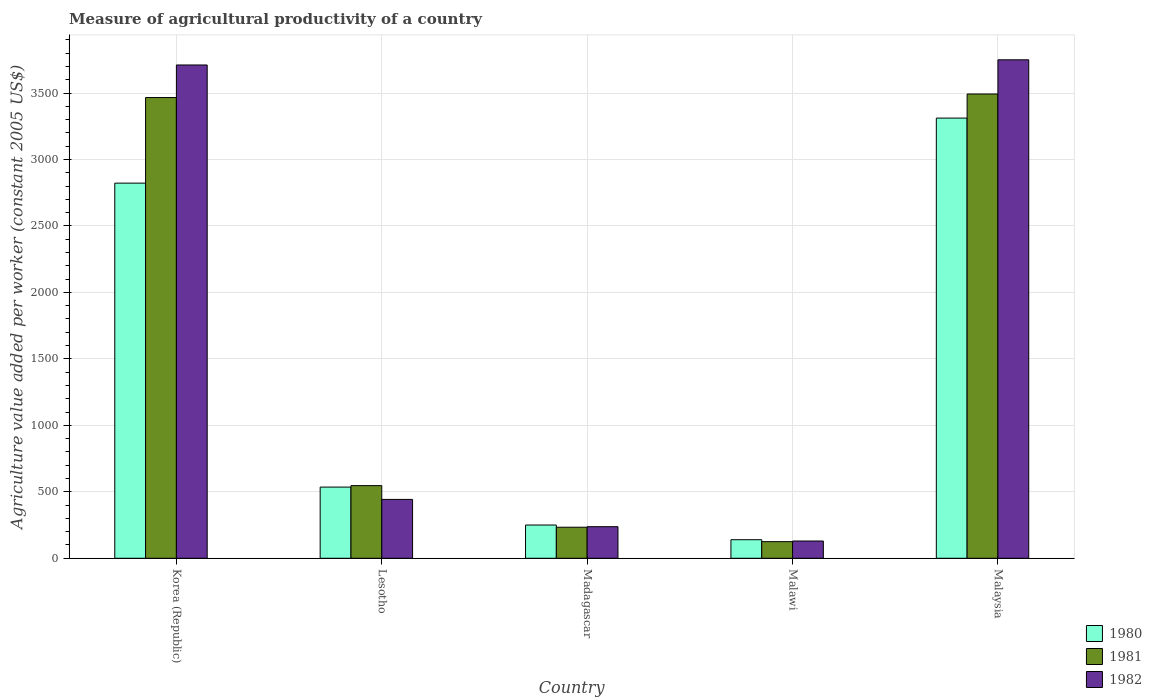How many groups of bars are there?
Offer a terse response. 5. Are the number of bars on each tick of the X-axis equal?
Provide a succinct answer. Yes. How many bars are there on the 4th tick from the right?
Keep it short and to the point. 3. What is the label of the 2nd group of bars from the left?
Ensure brevity in your answer.  Lesotho. What is the measure of agricultural productivity in 1981 in Malawi?
Provide a succinct answer. 124.86. Across all countries, what is the maximum measure of agricultural productivity in 1980?
Your response must be concise. 3311.27. Across all countries, what is the minimum measure of agricultural productivity in 1982?
Provide a succinct answer. 129.9. In which country was the measure of agricultural productivity in 1981 maximum?
Ensure brevity in your answer.  Malaysia. In which country was the measure of agricultural productivity in 1981 minimum?
Your answer should be very brief. Malawi. What is the total measure of agricultural productivity in 1981 in the graph?
Ensure brevity in your answer.  7863.25. What is the difference between the measure of agricultural productivity in 1982 in Lesotho and that in Malaysia?
Your response must be concise. -3307.03. What is the difference between the measure of agricultural productivity in 1982 in Malawi and the measure of agricultural productivity in 1980 in Korea (Republic)?
Keep it short and to the point. -2692.08. What is the average measure of agricultural productivity in 1982 per country?
Offer a terse response. 1654.19. What is the difference between the measure of agricultural productivity of/in 1982 and measure of agricultural productivity of/in 1980 in Malaysia?
Give a very brief answer. 438.53. What is the ratio of the measure of agricultural productivity in 1981 in Madagascar to that in Malaysia?
Provide a short and direct response. 0.07. Is the measure of agricultural productivity in 1980 in Lesotho less than that in Malawi?
Provide a succinct answer. No. What is the difference between the highest and the second highest measure of agricultural productivity in 1980?
Your answer should be very brief. -2286.45. What is the difference between the highest and the lowest measure of agricultural productivity in 1980?
Give a very brief answer. 3171.65. What does the 3rd bar from the left in Korea (Republic) represents?
Offer a very short reply. 1982. What does the 3rd bar from the right in Malaysia represents?
Provide a succinct answer. 1980. How many bars are there?
Offer a terse response. 15. Are all the bars in the graph horizontal?
Your answer should be very brief. No. Does the graph contain any zero values?
Make the answer very short. No. Does the graph contain grids?
Offer a very short reply. Yes. What is the title of the graph?
Offer a very short reply. Measure of agricultural productivity of a country. What is the label or title of the X-axis?
Provide a succinct answer. Country. What is the label or title of the Y-axis?
Offer a very short reply. Agriculture value added per worker (constant 2005 US$). What is the Agriculture value added per worker (constant 2005 US$) in 1980 in Korea (Republic)?
Offer a terse response. 2821.97. What is the Agriculture value added per worker (constant 2005 US$) of 1981 in Korea (Republic)?
Give a very brief answer. 3465.84. What is the Agriculture value added per worker (constant 2005 US$) in 1982 in Korea (Republic)?
Give a very brief answer. 3710.82. What is the Agriculture value added per worker (constant 2005 US$) in 1980 in Lesotho?
Ensure brevity in your answer.  535.53. What is the Agriculture value added per worker (constant 2005 US$) of 1981 in Lesotho?
Provide a succinct answer. 546.43. What is the Agriculture value added per worker (constant 2005 US$) of 1982 in Lesotho?
Your response must be concise. 442.77. What is the Agriculture value added per worker (constant 2005 US$) of 1980 in Madagascar?
Your answer should be compact. 250.1. What is the Agriculture value added per worker (constant 2005 US$) of 1981 in Madagascar?
Give a very brief answer. 233.51. What is the Agriculture value added per worker (constant 2005 US$) in 1982 in Madagascar?
Ensure brevity in your answer.  237.65. What is the Agriculture value added per worker (constant 2005 US$) in 1980 in Malawi?
Your answer should be very brief. 139.62. What is the Agriculture value added per worker (constant 2005 US$) of 1981 in Malawi?
Keep it short and to the point. 124.86. What is the Agriculture value added per worker (constant 2005 US$) of 1982 in Malawi?
Keep it short and to the point. 129.9. What is the Agriculture value added per worker (constant 2005 US$) of 1980 in Malaysia?
Ensure brevity in your answer.  3311.27. What is the Agriculture value added per worker (constant 2005 US$) of 1981 in Malaysia?
Provide a succinct answer. 3492.6. What is the Agriculture value added per worker (constant 2005 US$) in 1982 in Malaysia?
Provide a succinct answer. 3749.8. Across all countries, what is the maximum Agriculture value added per worker (constant 2005 US$) of 1980?
Your answer should be very brief. 3311.27. Across all countries, what is the maximum Agriculture value added per worker (constant 2005 US$) of 1981?
Your answer should be very brief. 3492.6. Across all countries, what is the maximum Agriculture value added per worker (constant 2005 US$) in 1982?
Keep it short and to the point. 3749.8. Across all countries, what is the minimum Agriculture value added per worker (constant 2005 US$) of 1980?
Give a very brief answer. 139.62. Across all countries, what is the minimum Agriculture value added per worker (constant 2005 US$) in 1981?
Make the answer very short. 124.86. Across all countries, what is the minimum Agriculture value added per worker (constant 2005 US$) of 1982?
Your response must be concise. 129.9. What is the total Agriculture value added per worker (constant 2005 US$) of 1980 in the graph?
Provide a short and direct response. 7058.5. What is the total Agriculture value added per worker (constant 2005 US$) in 1981 in the graph?
Provide a short and direct response. 7863.25. What is the total Agriculture value added per worker (constant 2005 US$) of 1982 in the graph?
Keep it short and to the point. 8270.93. What is the difference between the Agriculture value added per worker (constant 2005 US$) of 1980 in Korea (Republic) and that in Lesotho?
Ensure brevity in your answer.  2286.45. What is the difference between the Agriculture value added per worker (constant 2005 US$) of 1981 in Korea (Republic) and that in Lesotho?
Provide a succinct answer. 2919.41. What is the difference between the Agriculture value added per worker (constant 2005 US$) in 1982 in Korea (Republic) and that in Lesotho?
Offer a very short reply. 3268.05. What is the difference between the Agriculture value added per worker (constant 2005 US$) of 1980 in Korea (Republic) and that in Madagascar?
Offer a very short reply. 2571.88. What is the difference between the Agriculture value added per worker (constant 2005 US$) of 1981 in Korea (Republic) and that in Madagascar?
Provide a succinct answer. 3232.33. What is the difference between the Agriculture value added per worker (constant 2005 US$) in 1982 in Korea (Republic) and that in Madagascar?
Keep it short and to the point. 3473.17. What is the difference between the Agriculture value added per worker (constant 2005 US$) of 1980 in Korea (Republic) and that in Malawi?
Make the answer very short. 2682.35. What is the difference between the Agriculture value added per worker (constant 2005 US$) of 1981 in Korea (Republic) and that in Malawi?
Your response must be concise. 3340.98. What is the difference between the Agriculture value added per worker (constant 2005 US$) of 1982 in Korea (Republic) and that in Malawi?
Your response must be concise. 3580.92. What is the difference between the Agriculture value added per worker (constant 2005 US$) of 1980 in Korea (Republic) and that in Malaysia?
Offer a terse response. -489.3. What is the difference between the Agriculture value added per worker (constant 2005 US$) in 1981 in Korea (Republic) and that in Malaysia?
Your answer should be compact. -26.76. What is the difference between the Agriculture value added per worker (constant 2005 US$) of 1982 in Korea (Republic) and that in Malaysia?
Your answer should be very brief. -38.98. What is the difference between the Agriculture value added per worker (constant 2005 US$) of 1980 in Lesotho and that in Madagascar?
Your response must be concise. 285.43. What is the difference between the Agriculture value added per worker (constant 2005 US$) of 1981 in Lesotho and that in Madagascar?
Offer a terse response. 312.92. What is the difference between the Agriculture value added per worker (constant 2005 US$) in 1982 in Lesotho and that in Madagascar?
Make the answer very short. 205.12. What is the difference between the Agriculture value added per worker (constant 2005 US$) in 1980 in Lesotho and that in Malawi?
Ensure brevity in your answer.  395.9. What is the difference between the Agriculture value added per worker (constant 2005 US$) of 1981 in Lesotho and that in Malawi?
Keep it short and to the point. 421.57. What is the difference between the Agriculture value added per worker (constant 2005 US$) in 1982 in Lesotho and that in Malawi?
Provide a short and direct response. 312.87. What is the difference between the Agriculture value added per worker (constant 2005 US$) in 1980 in Lesotho and that in Malaysia?
Keep it short and to the point. -2775.74. What is the difference between the Agriculture value added per worker (constant 2005 US$) of 1981 in Lesotho and that in Malaysia?
Your answer should be very brief. -2946.17. What is the difference between the Agriculture value added per worker (constant 2005 US$) of 1982 in Lesotho and that in Malaysia?
Provide a succinct answer. -3307.03. What is the difference between the Agriculture value added per worker (constant 2005 US$) in 1980 in Madagascar and that in Malawi?
Offer a very short reply. 110.47. What is the difference between the Agriculture value added per worker (constant 2005 US$) in 1981 in Madagascar and that in Malawi?
Your response must be concise. 108.65. What is the difference between the Agriculture value added per worker (constant 2005 US$) of 1982 in Madagascar and that in Malawi?
Provide a succinct answer. 107.75. What is the difference between the Agriculture value added per worker (constant 2005 US$) in 1980 in Madagascar and that in Malaysia?
Ensure brevity in your answer.  -3061.17. What is the difference between the Agriculture value added per worker (constant 2005 US$) of 1981 in Madagascar and that in Malaysia?
Your response must be concise. -3259.09. What is the difference between the Agriculture value added per worker (constant 2005 US$) of 1982 in Madagascar and that in Malaysia?
Ensure brevity in your answer.  -3512.15. What is the difference between the Agriculture value added per worker (constant 2005 US$) of 1980 in Malawi and that in Malaysia?
Your response must be concise. -3171.65. What is the difference between the Agriculture value added per worker (constant 2005 US$) in 1981 in Malawi and that in Malaysia?
Provide a succinct answer. -3367.74. What is the difference between the Agriculture value added per worker (constant 2005 US$) of 1982 in Malawi and that in Malaysia?
Your response must be concise. -3619.9. What is the difference between the Agriculture value added per worker (constant 2005 US$) of 1980 in Korea (Republic) and the Agriculture value added per worker (constant 2005 US$) of 1981 in Lesotho?
Offer a very short reply. 2275.55. What is the difference between the Agriculture value added per worker (constant 2005 US$) in 1980 in Korea (Republic) and the Agriculture value added per worker (constant 2005 US$) in 1982 in Lesotho?
Keep it short and to the point. 2379.21. What is the difference between the Agriculture value added per worker (constant 2005 US$) of 1981 in Korea (Republic) and the Agriculture value added per worker (constant 2005 US$) of 1982 in Lesotho?
Ensure brevity in your answer.  3023.08. What is the difference between the Agriculture value added per worker (constant 2005 US$) of 1980 in Korea (Republic) and the Agriculture value added per worker (constant 2005 US$) of 1981 in Madagascar?
Your response must be concise. 2588.46. What is the difference between the Agriculture value added per worker (constant 2005 US$) of 1980 in Korea (Republic) and the Agriculture value added per worker (constant 2005 US$) of 1982 in Madagascar?
Offer a very short reply. 2584.33. What is the difference between the Agriculture value added per worker (constant 2005 US$) in 1981 in Korea (Republic) and the Agriculture value added per worker (constant 2005 US$) in 1982 in Madagascar?
Ensure brevity in your answer.  3228.2. What is the difference between the Agriculture value added per worker (constant 2005 US$) in 1980 in Korea (Republic) and the Agriculture value added per worker (constant 2005 US$) in 1981 in Malawi?
Offer a very short reply. 2697.11. What is the difference between the Agriculture value added per worker (constant 2005 US$) in 1980 in Korea (Republic) and the Agriculture value added per worker (constant 2005 US$) in 1982 in Malawi?
Your response must be concise. 2692.08. What is the difference between the Agriculture value added per worker (constant 2005 US$) in 1981 in Korea (Republic) and the Agriculture value added per worker (constant 2005 US$) in 1982 in Malawi?
Ensure brevity in your answer.  3335.95. What is the difference between the Agriculture value added per worker (constant 2005 US$) in 1980 in Korea (Republic) and the Agriculture value added per worker (constant 2005 US$) in 1981 in Malaysia?
Make the answer very short. -670.63. What is the difference between the Agriculture value added per worker (constant 2005 US$) of 1980 in Korea (Republic) and the Agriculture value added per worker (constant 2005 US$) of 1982 in Malaysia?
Give a very brief answer. -927.83. What is the difference between the Agriculture value added per worker (constant 2005 US$) of 1981 in Korea (Republic) and the Agriculture value added per worker (constant 2005 US$) of 1982 in Malaysia?
Your answer should be very brief. -283.96. What is the difference between the Agriculture value added per worker (constant 2005 US$) of 1980 in Lesotho and the Agriculture value added per worker (constant 2005 US$) of 1981 in Madagascar?
Offer a terse response. 302.02. What is the difference between the Agriculture value added per worker (constant 2005 US$) of 1980 in Lesotho and the Agriculture value added per worker (constant 2005 US$) of 1982 in Madagascar?
Offer a very short reply. 297.88. What is the difference between the Agriculture value added per worker (constant 2005 US$) in 1981 in Lesotho and the Agriculture value added per worker (constant 2005 US$) in 1982 in Madagascar?
Your answer should be very brief. 308.78. What is the difference between the Agriculture value added per worker (constant 2005 US$) in 1980 in Lesotho and the Agriculture value added per worker (constant 2005 US$) in 1981 in Malawi?
Your response must be concise. 410.66. What is the difference between the Agriculture value added per worker (constant 2005 US$) of 1980 in Lesotho and the Agriculture value added per worker (constant 2005 US$) of 1982 in Malawi?
Offer a very short reply. 405.63. What is the difference between the Agriculture value added per worker (constant 2005 US$) in 1981 in Lesotho and the Agriculture value added per worker (constant 2005 US$) in 1982 in Malawi?
Provide a succinct answer. 416.53. What is the difference between the Agriculture value added per worker (constant 2005 US$) of 1980 in Lesotho and the Agriculture value added per worker (constant 2005 US$) of 1981 in Malaysia?
Give a very brief answer. -2957.07. What is the difference between the Agriculture value added per worker (constant 2005 US$) of 1980 in Lesotho and the Agriculture value added per worker (constant 2005 US$) of 1982 in Malaysia?
Give a very brief answer. -3214.27. What is the difference between the Agriculture value added per worker (constant 2005 US$) of 1981 in Lesotho and the Agriculture value added per worker (constant 2005 US$) of 1982 in Malaysia?
Offer a very short reply. -3203.37. What is the difference between the Agriculture value added per worker (constant 2005 US$) of 1980 in Madagascar and the Agriculture value added per worker (constant 2005 US$) of 1981 in Malawi?
Keep it short and to the point. 125.24. What is the difference between the Agriculture value added per worker (constant 2005 US$) of 1980 in Madagascar and the Agriculture value added per worker (constant 2005 US$) of 1982 in Malawi?
Provide a succinct answer. 120.2. What is the difference between the Agriculture value added per worker (constant 2005 US$) of 1981 in Madagascar and the Agriculture value added per worker (constant 2005 US$) of 1982 in Malawi?
Offer a terse response. 103.61. What is the difference between the Agriculture value added per worker (constant 2005 US$) in 1980 in Madagascar and the Agriculture value added per worker (constant 2005 US$) in 1981 in Malaysia?
Provide a succinct answer. -3242.5. What is the difference between the Agriculture value added per worker (constant 2005 US$) in 1980 in Madagascar and the Agriculture value added per worker (constant 2005 US$) in 1982 in Malaysia?
Keep it short and to the point. -3499.7. What is the difference between the Agriculture value added per worker (constant 2005 US$) of 1981 in Madagascar and the Agriculture value added per worker (constant 2005 US$) of 1982 in Malaysia?
Provide a succinct answer. -3516.29. What is the difference between the Agriculture value added per worker (constant 2005 US$) of 1980 in Malawi and the Agriculture value added per worker (constant 2005 US$) of 1981 in Malaysia?
Your answer should be compact. -3352.98. What is the difference between the Agriculture value added per worker (constant 2005 US$) of 1980 in Malawi and the Agriculture value added per worker (constant 2005 US$) of 1982 in Malaysia?
Make the answer very short. -3610.18. What is the difference between the Agriculture value added per worker (constant 2005 US$) of 1981 in Malawi and the Agriculture value added per worker (constant 2005 US$) of 1982 in Malaysia?
Make the answer very short. -3624.94. What is the average Agriculture value added per worker (constant 2005 US$) of 1980 per country?
Keep it short and to the point. 1411.7. What is the average Agriculture value added per worker (constant 2005 US$) in 1981 per country?
Keep it short and to the point. 1572.65. What is the average Agriculture value added per worker (constant 2005 US$) in 1982 per country?
Your answer should be very brief. 1654.19. What is the difference between the Agriculture value added per worker (constant 2005 US$) of 1980 and Agriculture value added per worker (constant 2005 US$) of 1981 in Korea (Republic)?
Your answer should be very brief. -643.87. What is the difference between the Agriculture value added per worker (constant 2005 US$) in 1980 and Agriculture value added per worker (constant 2005 US$) in 1982 in Korea (Republic)?
Make the answer very short. -888.84. What is the difference between the Agriculture value added per worker (constant 2005 US$) of 1981 and Agriculture value added per worker (constant 2005 US$) of 1982 in Korea (Republic)?
Make the answer very short. -244.97. What is the difference between the Agriculture value added per worker (constant 2005 US$) of 1980 and Agriculture value added per worker (constant 2005 US$) of 1981 in Lesotho?
Your response must be concise. -10.9. What is the difference between the Agriculture value added per worker (constant 2005 US$) of 1980 and Agriculture value added per worker (constant 2005 US$) of 1982 in Lesotho?
Your answer should be compact. 92.76. What is the difference between the Agriculture value added per worker (constant 2005 US$) of 1981 and Agriculture value added per worker (constant 2005 US$) of 1982 in Lesotho?
Your answer should be very brief. 103.66. What is the difference between the Agriculture value added per worker (constant 2005 US$) of 1980 and Agriculture value added per worker (constant 2005 US$) of 1981 in Madagascar?
Offer a terse response. 16.59. What is the difference between the Agriculture value added per worker (constant 2005 US$) in 1980 and Agriculture value added per worker (constant 2005 US$) in 1982 in Madagascar?
Offer a very short reply. 12.45. What is the difference between the Agriculture value added per worker (constant 2005 US$) of 1981 and Agriculture value added per worker (constant 2005 US$) of 1982 in Madagascar?
Your response must be concise. -4.13. What is the difference between the Agriculture value added per worker (constant 2005 US$) of 1980 and Agriculture value added per worker (constant 2005 US$) of 1981 in Malawi?
Make the answer very short. 14.76. What is the difference between the Agriculture value added per worker (constant 2005 US$) of 1980 and Agriculture value added per worker (constant 2005 US$) of 1982 in Malawi?
Keep it short and to the point. 9.73. What is the difference between the Agriculture value added per worker (constant 2005 US$) of 1981 and Agriculture value added per worker (constant 2005 US$) of 1982 in Malawi?
Make the answer very short. -5.03. What is the difference between the Agriculture value added per worker (constant 2005 US$) of 1980 and Agriculture value added per worker (constant 2005 US$) of 1981 in Malaysia?
Your answer should be very brief. -181.33. What is the difference between the Agriculture value added per worker (constant 2005 US$) in 1980 and Agriculture value added per worker (constant 2005 US$) in 1982 in Malaysia?
Make the answer very short. -438.53. What is the difference between the Agriculture value added per worker (constant 2005 US$) in 1981 and Agriculture value added per worker (constant 2005 US$) in 1982 in Malaysia?
Your answer should be very brief. -257.2. What is the ratio of the Agriculture value added per worker (constant 2005 US$) of 1980 in Korea (Republic) to that in Lesotho?
Keep it short and to the point. 5.27. What is the ratio of the Agriculture value added per worker (constant 2005 US$) in 1981 in Korea (Republic) to that in Lesotho?
Keep it short and to the point. 6.34. What is the ratio of the Agriculture value added per worker (constant 2005 US$) of 1982 in Korea (Republic) to that in Lesotho?
Provide a succinct answer. 8.38. What is the ratio of the Agriculture value added per worker (constant 2005 US$) of 1980 in Korea (Republic) to that in Madagascar?
Offer a terse response. 11.28. What is the ratio of the Agriculture value added per worker (constant 2005 US$) of 1981 in Korea (Republic) to that in Madagascar?
Ensure brevity in your answer.  14.84. What is the ratio of the Agriculture value added per worker (constant 2005 US$) in 1982 in Korea (Republic) to that in Madagascar?
Ensure brevity in your answer.  15.61. What is the ratio of the Agriculture value added per worker (constant 2005 US$) in 1980 in Korea (Republic) to that in Malawi?
Keep it short and to the point. 20.21. What is the ratio of the Agriculture value added per worker (constant 2005 US$) in 1981 in Korea (Republic) to that in Malawi?
Keep it short and to the point. 27.76. What is the ratio of the Agriculture value added per worker (constant 2005 US$) in 1982 in Korea (Republic) to that in Malawi?
Your answer should be very brief. 28.57. What is the ratio of the Agriculture value added per worker (constant 2005 US$) in 1980 in Korea (Republic) to that in Malaysia?
Your answer should be compact. 0.85. What is the ratio of the Agriculture value added per worker (constant 2005 US$) of 1981 in Korea (Republic) to that in Malaysia?
Your response must be concise. 0.99. What is the ratio of the Agriculture value added per worker (constant 2005 US$) in 1982 in Korea (Republic) to that in Malaysia?
Ensure brevity in your answer.  0.99. What is the ratio of the Agriculture value added per worker (constant 2005 US$) in 1980 in Lesotho to that in Madagascar?
Your answer should be very brief. 2.14. What is the ratio of the Agriculture value added per worker (constant 2005 US$) of 1981 in Lesotho to that in Madagascar?
Your answer should be very brief. 2.34. What is the ratio of the Agriculture value added per worker (constant 2005 US$) of 1982 in Lesotho to that in Madagascar?
Offer a very short reply. 1.86. What is the ratio of the Agriculture value added per worker (constant 2005 US$) of 1980 in Lesotho to that in Malawi?
Ensure brevity in your answer.  3.84. What is the ratio of the Agriculture value added per worker (constant 2005 US$) of 1981 in Lesotho to that in Malawi?
Provide a succinct answer. 4.38. What is the ratio of the Agriculture value added per worker (constant 2005 US$) in 1982 in Lesotho to that in Malawi?
Your answer should be compact. 3.41. What is the ratio of the Agriculture value added per worker (constant 2005 US$) of 1980 in Lesotho to that in Malaysia?
Provide a short and direct response. 0.16. What is the ratio of the Agriculture value added per worker (constant 2005 US$) in 1981 in Lesotho to that in Malaysia?
Your answer should be compact. 0.16. What is the ratio of the Agriculture value added per worker (constant 2005 US$) of 1982 in Lesotho to that in Malaysia?
Provide a short and direct response. 0.12. What is the ratio of the Agriculture value added per worker (constant 2005 US$) of 1980 in Madagascar to that in Malawi?
Provide a succinct answer. 1.79. What is the ratio of the Agriculture value added per worker (constant 2005 US$) of 1981 in Madagascar to that in Malawi?
Offer a very short reply. 1.87. What is the ratio of the Agriculture value added per worker (constant 2005 US$) of 1982 in Madagascar to that in Malawi?
Keep it short and to the point. 1.83. What is the ratio of the Agriculture value added per worker (constant 2005 US$) in 1980 in Madagascar to that in Malaysia?
Provide a short and direct response. 0.08. What is the ratio of the Agriculture value added per worker (constant 2005 US$) of 1981 in Madagascar to that in Malaysia?
Your response must be concise. 0.07. What is the ratio of the Agriculture value added per worker (constant 2005 US$) of 1982 in Madagascar to that in Malaysia?
Provide a succinct answer. 0.06. What is the ratio of the Agriculture value added per worker (constant 2005 US$) of 1980 in Malawi to that in Malaysia?
Provide a succinct answer. 0.04. What is the ratio of the Agriculture value added per worker (constant 2005 US$) in 1981 in Malawi to that in Malaysia?
Make the answer very short. 0.04. What is the ratio of the Agriculture value added per worker (constant 2005 US$) in 1982 in Malawi to that in Malaysia?
Your response must be concise. 0.03. What is the difference between the highest and the second highest Agriculture value added per worker (constant 2005 US$) in 1980?
Provide a succinct answer. 489.3. What is the difference between the highest and the second highest Agriculture value added per worker (constant 2005 US$) of 1981?
Your response must be concise. 26.76. What is the difference between the highest and the second highest Agriculture value added per worker (constant 2005 US$) of 1982?
Your answer should be very brief. 38.98. What is the difference between the highest and the lowest Agriculture value added per worker (constant 2005 US$) in 1980?
Your response must be concise. 3171.65. What is the difference between the highest and the lowest Agriculture value added per worker (constant 2005 US$) of 1981?
Your answer should be compact. 3367.74. What is the difference between the highest and the lowest Agriculture value added per worker (constant 2005 US$) in 1982?
Provide a succinct answer. 3619.9. 